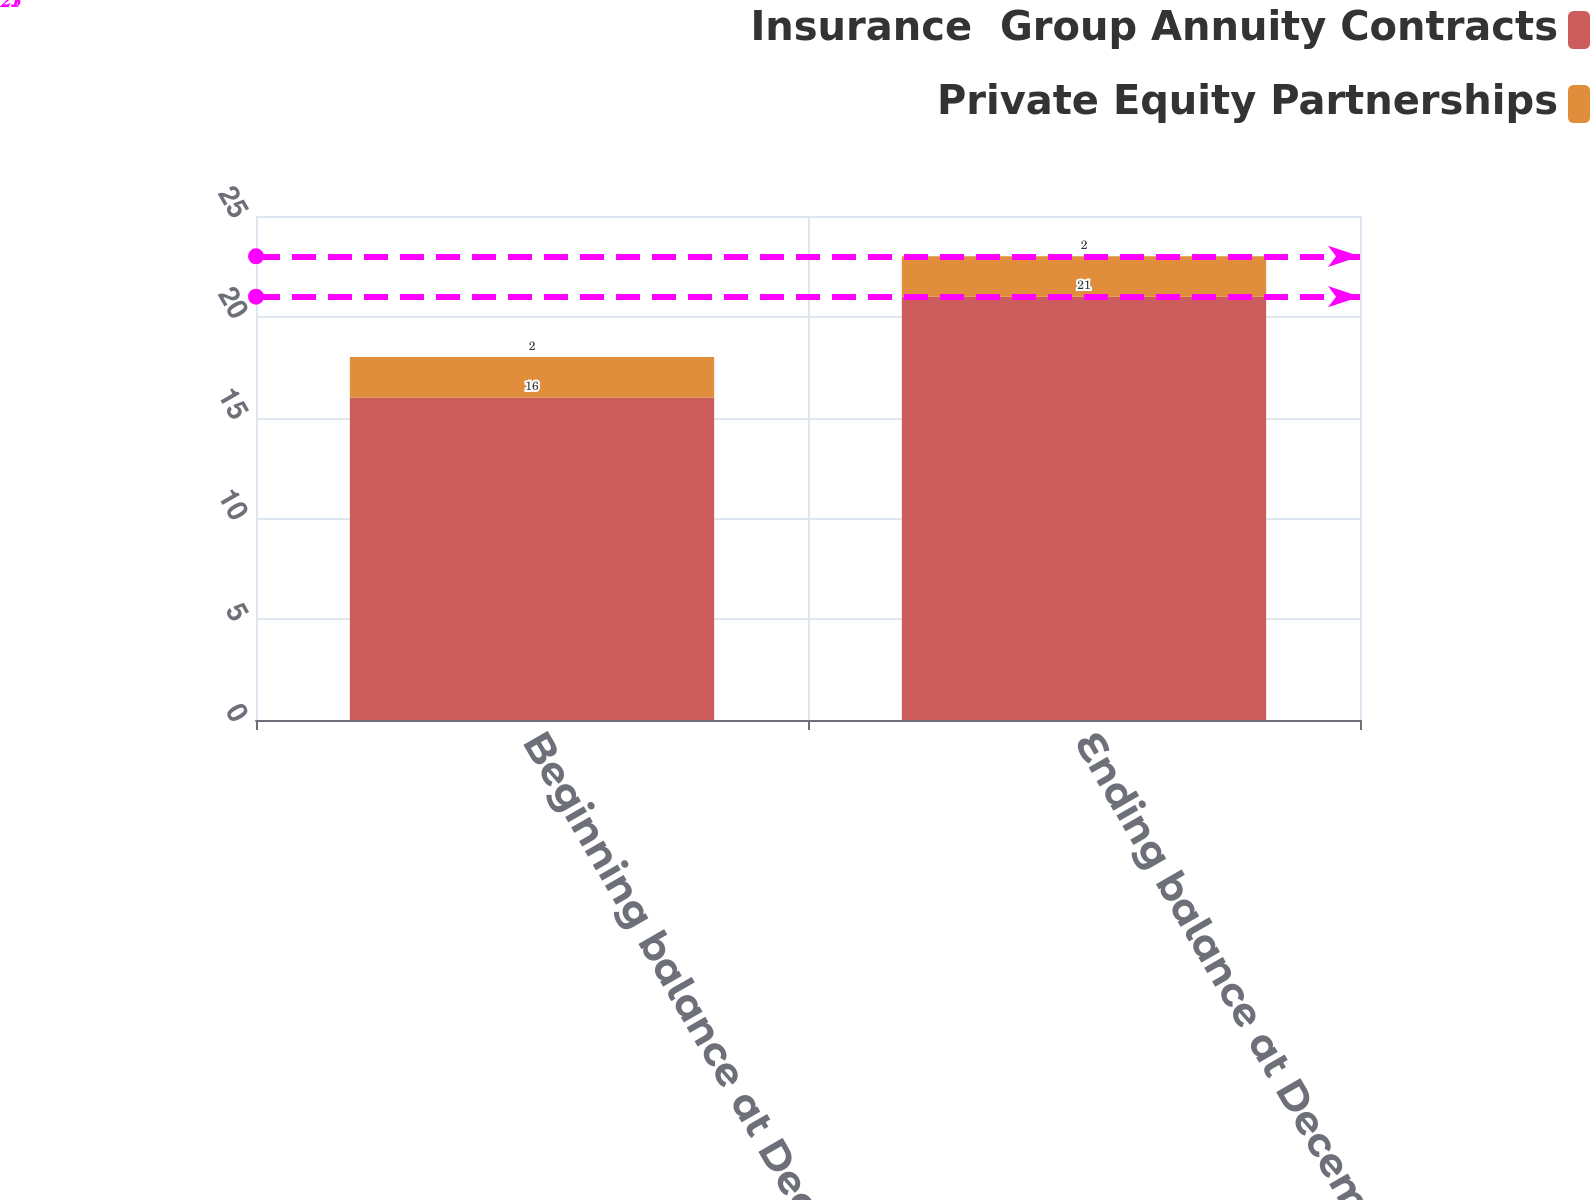Convert chart. <chart><loc_0><loc_0><loc_500><loc_500><stacked_bar_chart><ecel><fcel>Beginning balance at December<fcel>Ending balance at December 31<nl><fcel>Insurance  Group Annuity Contracts<fcel>16<fcel>21<nl><fcel>Private Equity Partnerships<fcel>2<fcel>2<nl></chart> 